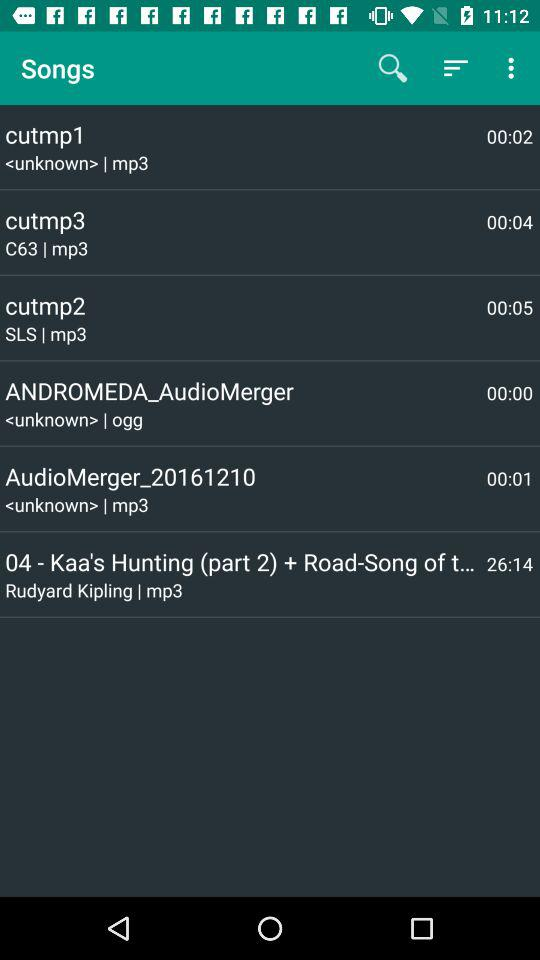What is the audio format of the song Cutmp2? The format is mp3. 